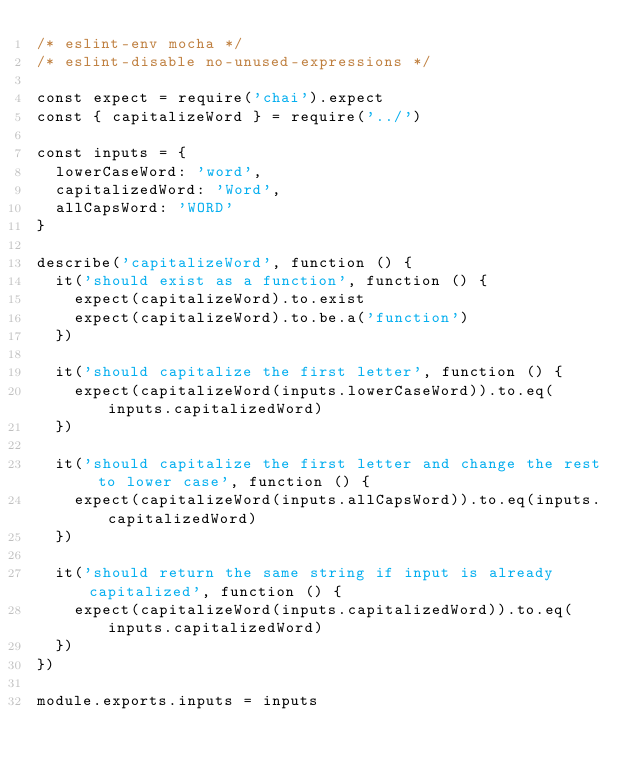Convert code to text. <code><loc_0><loc_0><loc_500><loc_500><_JavaScript_>/* eslint-env mocha */
/* eslint-disable no-unused-expressions */

const expect = require('chai').expect
const { capitalizeWord } = require('../')

const inputs = {
  lowerCaseWord: 'word',
  capitalizedWord: 'Word',
  allCapsWord: 'WORD'
}

describe('capitalizeWord', function () {
  it('should exist as a function', function () {
    expect(capitalizeWord).to.exist
    expect(capitalizeWord).to.be.a('function')
  })

  it('should capitalize the first letter', function () {
    expect(capitalizeWord(inputs.lowerCaseWord)).to.eq(inputs.capitalizedWord)
  })

  it('should capitalize the first letter and change the rest to lower case', function () {
    expect(capitalizeWord(inputs.allCapsWord)).to.eq(inputs.capitalizedWord)
  })

  it('should return the same string if input is already capitalized', function () {
    expect(capitalizeWord(inputs.capitalizedWord)).to.eq(inputs.capitalizedWord)
  })
})

module.exports.inputs = inputs
</code> 